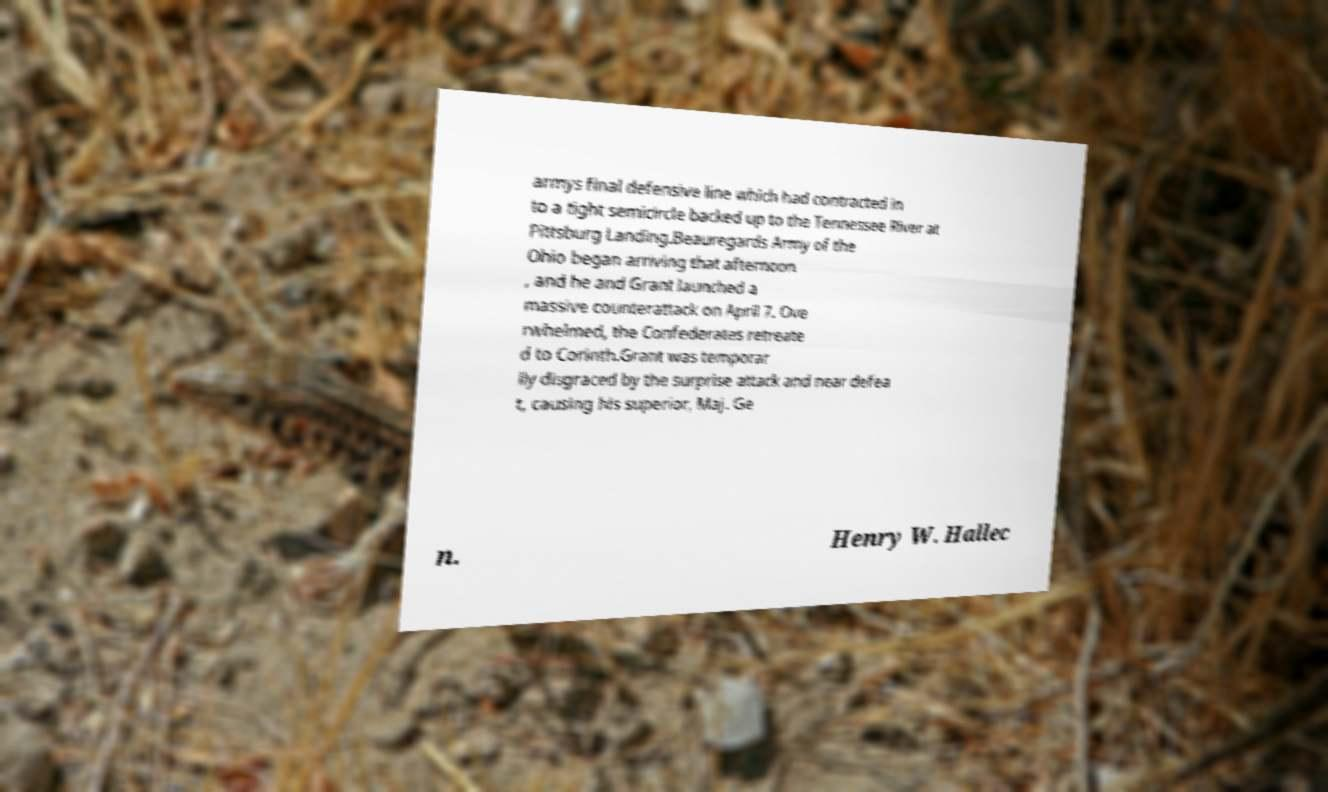Can you accurately transcribe the text from the provided image for me? armys final defensive line which had contracted in to a tight semicircle backed up to the Tennessee River at Pittsburg Landing.Beauregards Army of the Ohio began arriving that afternoon , and he and Grant launched a massive counterattack on April 7. Ove rwhelmed, the Confederates retreate d to Corinth.Grant was temporar ily disgraced by the surprise attack and near defea t, causing his superior, Maj. Ge n. Henry W. Hallec 